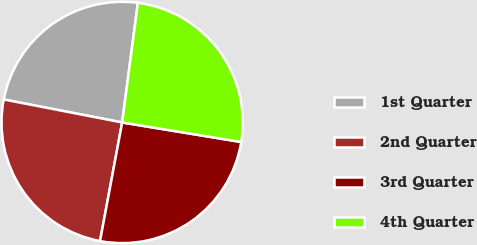Convert chart. <chart><loc_0><loc_0><loc_500><loc_500><pie_chart><fcel>1st Quarter<fcel>2nd Quarter<fcel>3rd Quarter<fcel>4th Quarter<nl><fcel>24.03%<fcel>25.12%<fcel>25.35%<fcel>25.51%<nl></chart> 